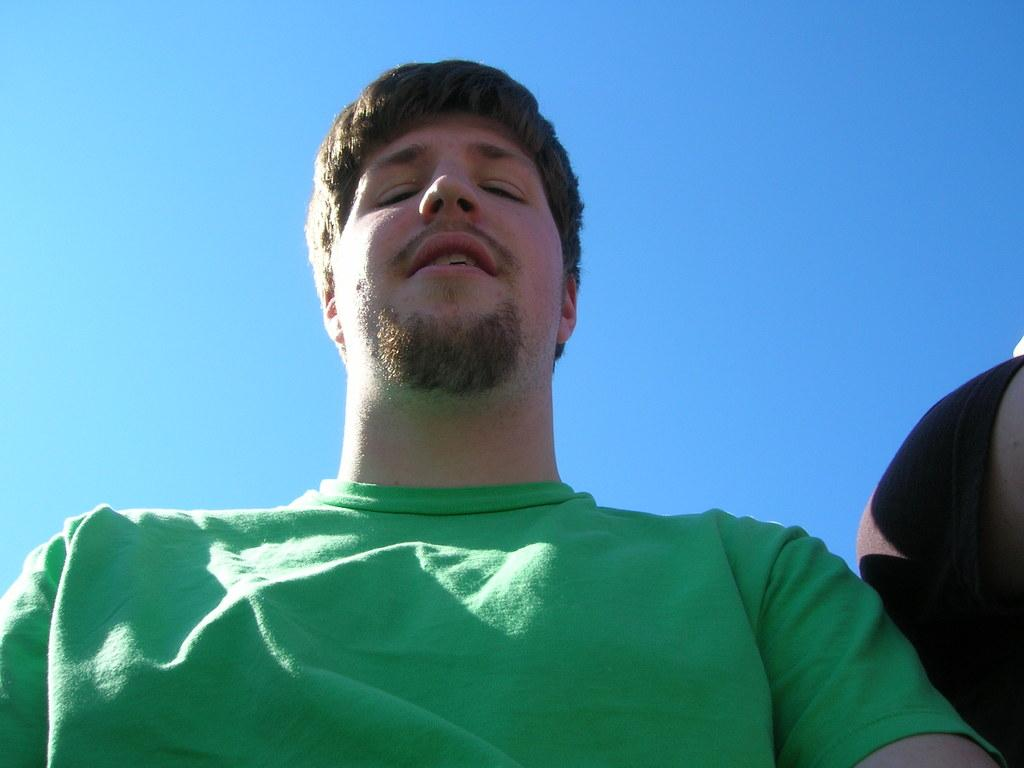What is present in the image? There is a man in the image. Can you describe what the man is wearing? The man is wearing a green T-shirt. What can be seen in the background of the image? There is the sky visible in the background of the image. How many feet of oatmeal can be seen in the image? There is no oatmeal present in the image, so it is not possible to determine the length of any oatmeal. What color is the man's eye in the image? The provided facts do not mention the color of the man's eye, so it cannot be determined from the image. 